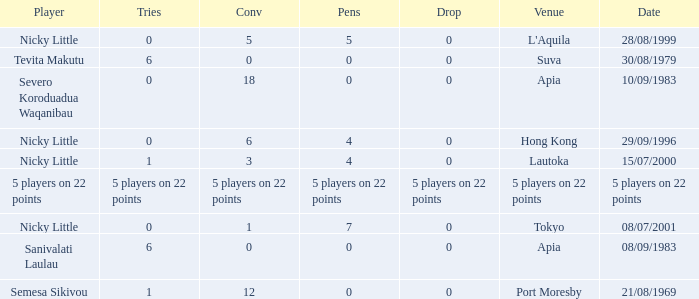How many drops did Nicky Little have in Hong Kong? 0.0. 